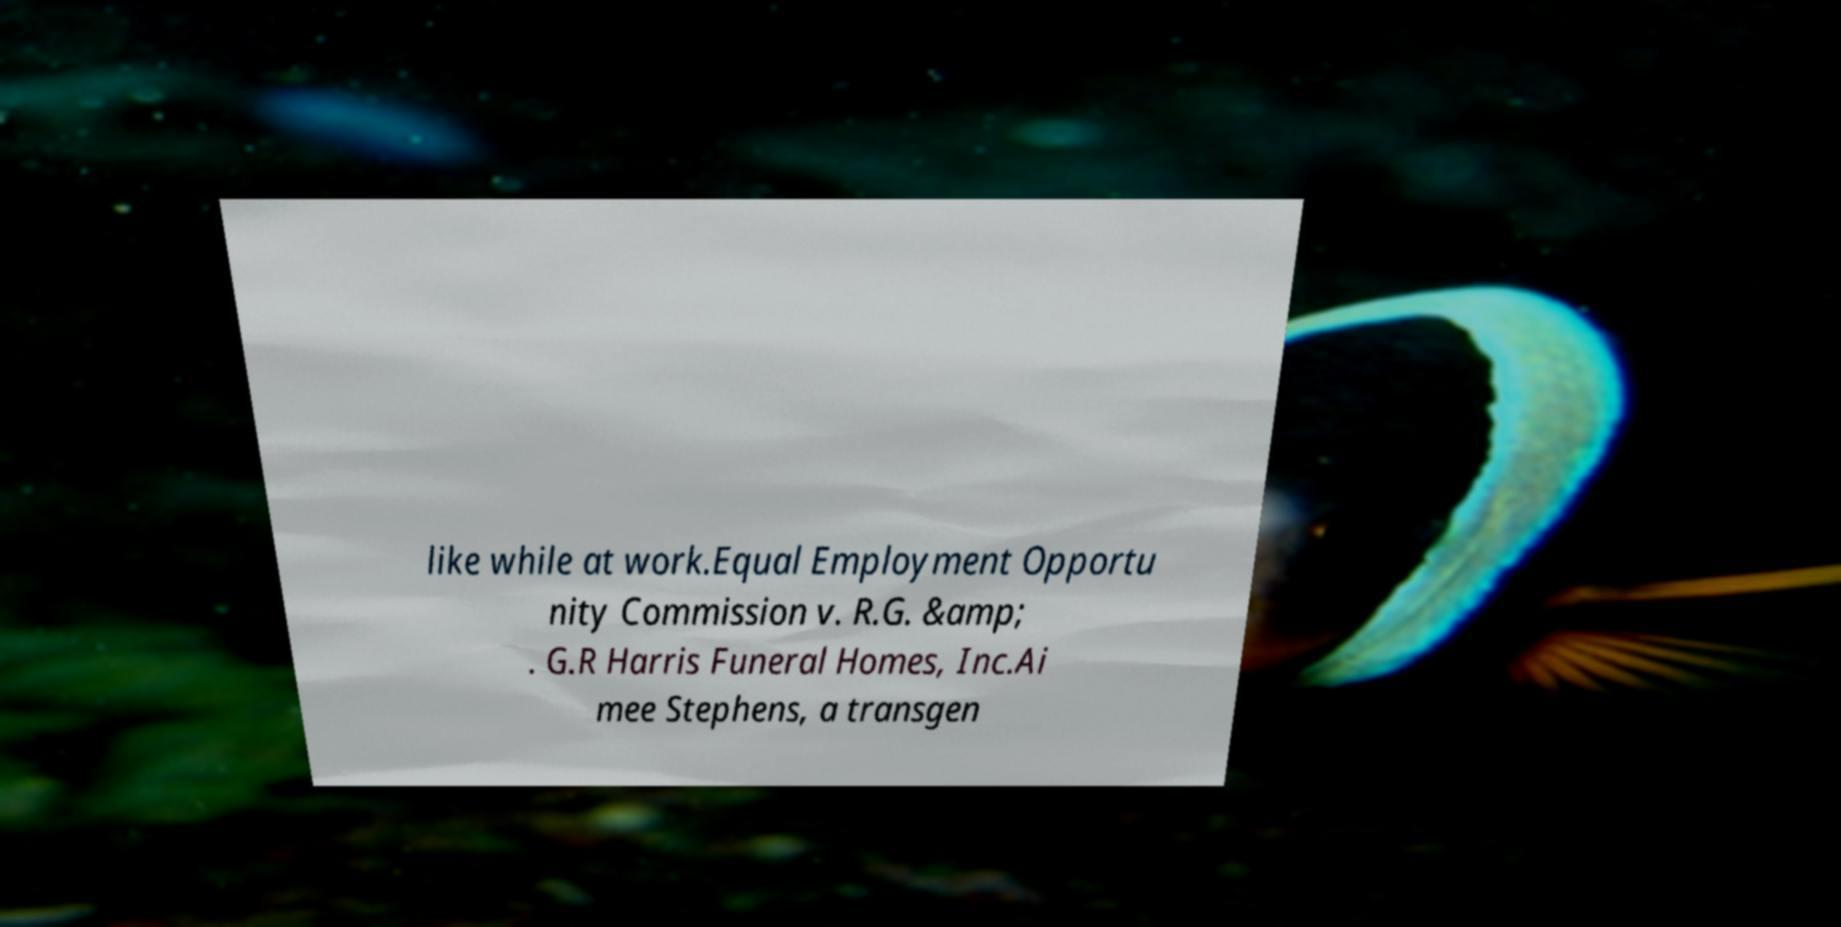Could you assist in decoding the text presented in this image and type it out clearly? like while at work.Equal Employment Opportu nity Commission v. R.G. &amp; . G.R Harris Funeral Homes, Inc.Ai mee Stephens, a transgen 